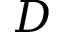<formula> <loc_0><loc_0><loc_500><loc_500>D</formula> 